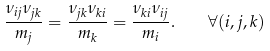<formula> <loc_0><loc_0><loc_500><loc_500>\frac { \nu _ { i j } \nu _ { j k } } { m _ { j } } = \frac { \nu _ { j k } \nu _ { k i } } { m _ { k } } = \frac { \nu _ { k i } \nu _ { i j } } { m _ { i } } . \quad \forall ( i , j , k )</formula> 